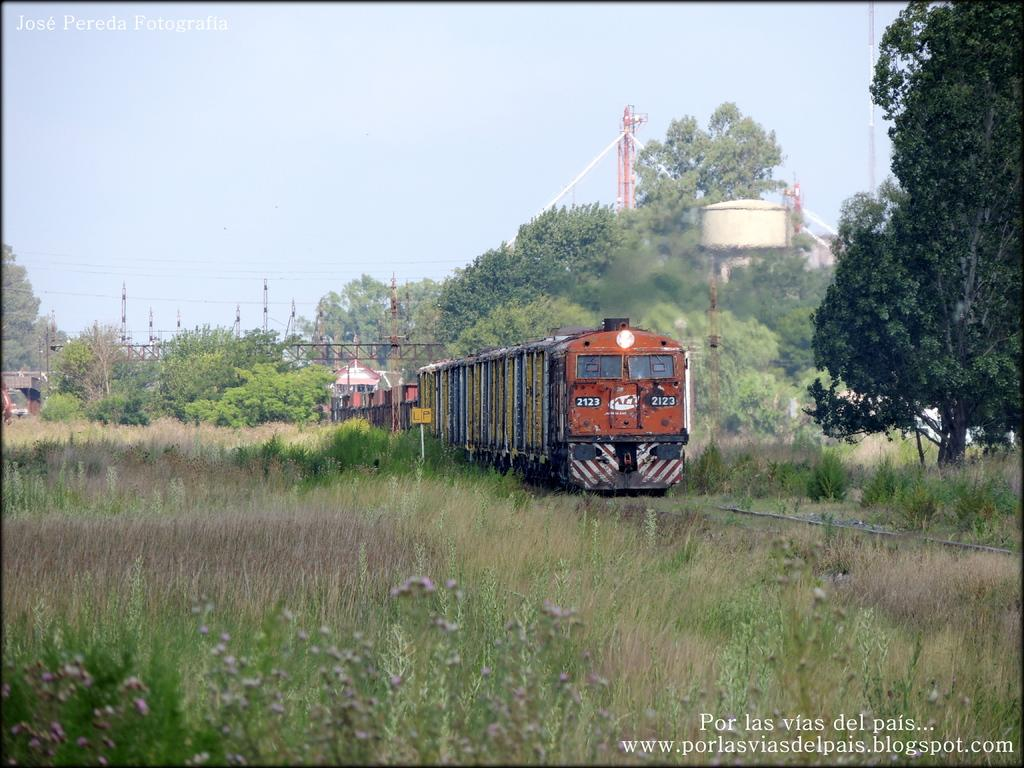<image>
Offer a succinct explanation of the picture presented. A train 2123 runs along the track through the grassland. 